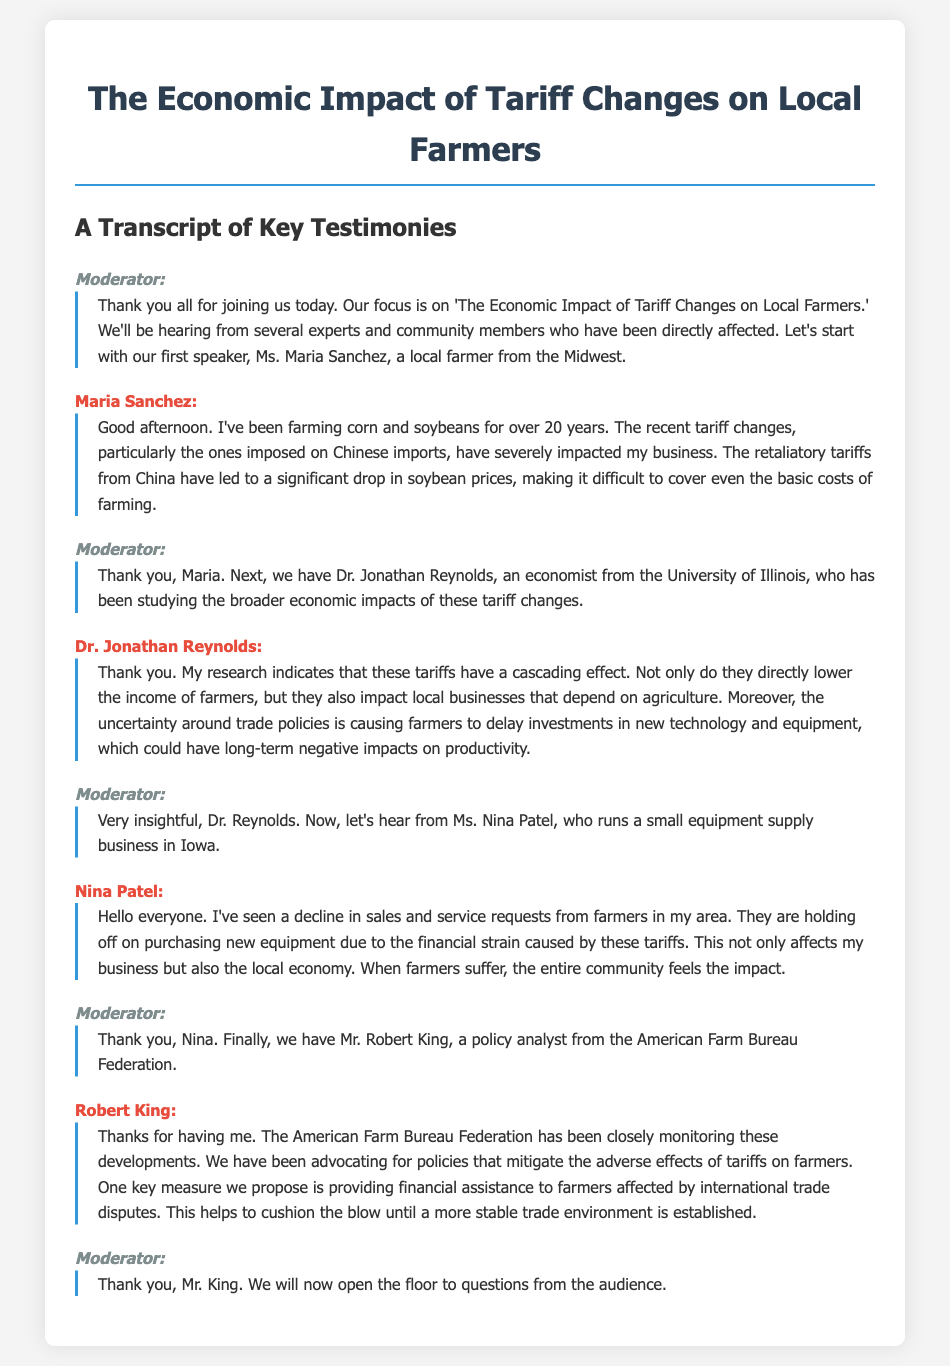What is the main focus of the discussion? The main focus is on 'The Economic Impact of Tariff Changes on Local Farmers.'
Answer: Economic Impact of Tariff Changes on Local Farmers Who is the first speaker in the transcript? The first speaker is identified as Ms. Maria Sanchez, a local farmer from the Midwest.
Answer: Ms. Maria Sanchez What commodity is mentioned as having a significant price drop? The commodity significantly affected is soybeans, due to retaliatory tariffs.
Answer: Soybeans What is one of the proposed measures by Robert King? One proposed measure is providing financial assistance to farmers affected by international trade disputes.
Answer: Financial assistance Which state does Nina Patel's equipment supply business operate in? Nina Patel runs her business in Iowa.
Answer: Iowa How many years has Maria Sanchez been farming? Maria Sanchez has been farming for over 20 years.
Answer: 20 years What is Dr. Jonathan Reynolds's profession? Dr. Jonathan Reynolds is an economist from the University of Illinois.
Answer: Economist What effect does uncertainty around trade policies have on farmers? It causes farmers to delay investments in new technology and equipment.
Answer: Delay investments What organization does Robert King represent? Robert King represents the American Farm Bureau Federation.
Answer: American Farm Bureau Federation 